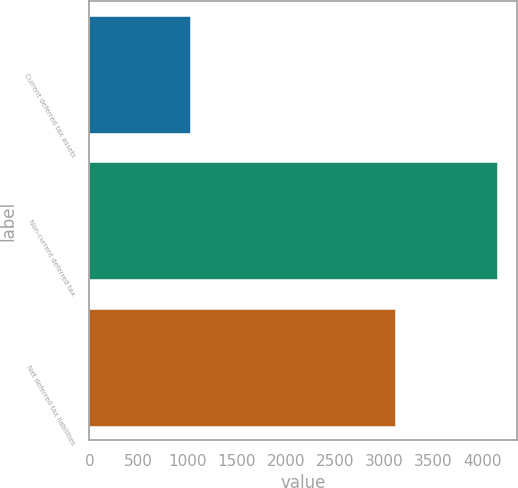<chart> <loc_0><loc_0><loc_500><loc_500><bar_chart><fcel>Current deferred tax assets<fcel>Non-current deferred tax<fcel>Net deferred tax liabilities<nl><fcel>1028<fcel>4145<fcel>3109<nl></chart> 